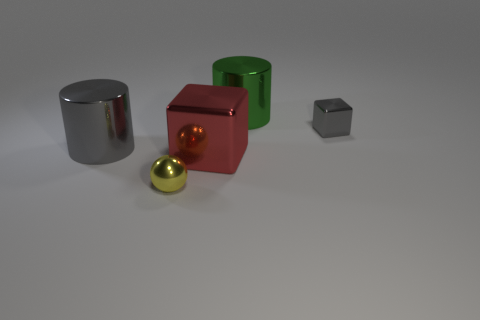Add 3 tiny metallic spheres. How many objects exist? 8 Add 1 red metal cubes. How many red metal cubes exist? 2 Subtract 0 purple cubes. How many objects are left? 5 Subtract all spheres. How many objects are left? 4 Subtract all large yellow blocks. Subtract all gray blocks. How many objects are left? 4 Add 1 red shiny objects. How many red shiny objects are left? 2 